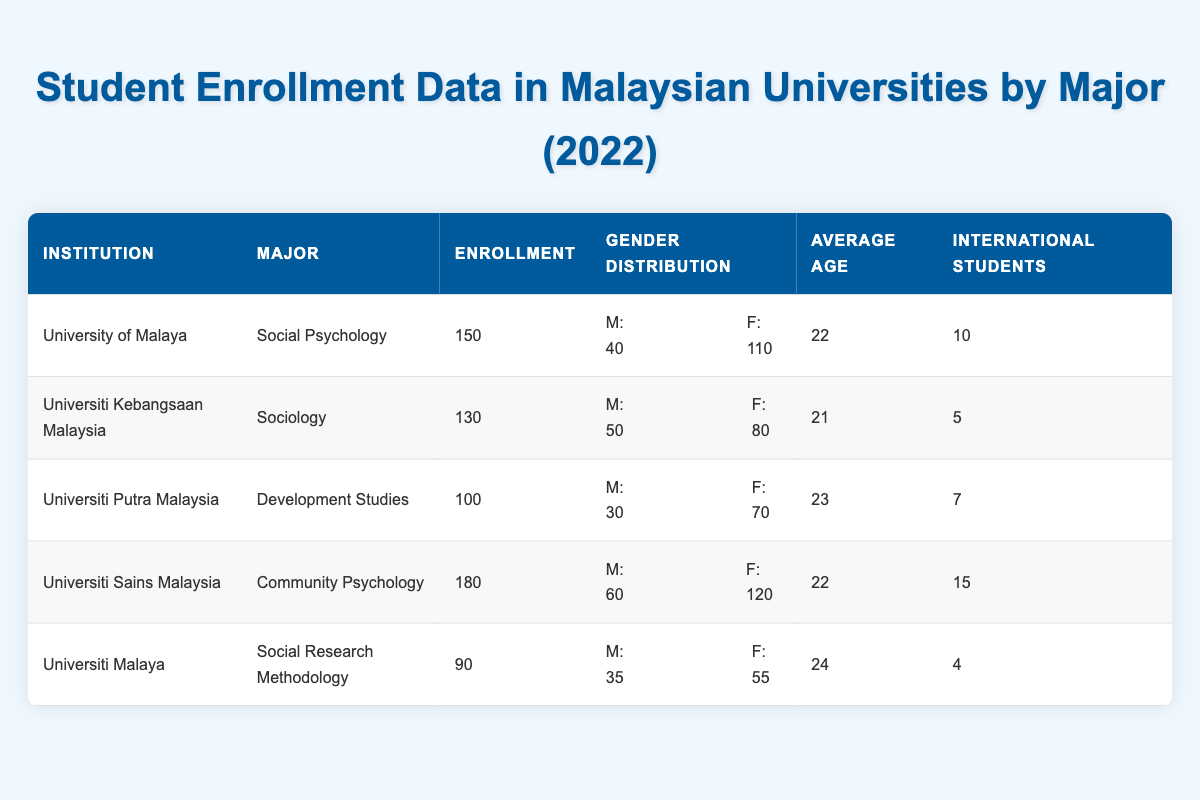What is the total enrollment for Social Psychology majors in Malaysian universities? According to the table, the enrollment numbers for Social Psychology are as follows: University of Malaya has 150. Therefore, the total enrollment for Social Psychology majors is 150.
Answer: 150 Which institution has the highest number of female students in their programs? From the data, Universiti Sains Malaysia has 120 female students in Community Psychology, which is the highest compared to other institutions.
Answer: Universiti Sains Malaysia What is the average age of students enrolled in Sociology? The table shows that the average age of students in Sociology at Universiti Kebangsaan Malaysia is 21.
Answer: 21 How many international students are enrolled in Development Studies? According to the table, Universiti Putra Malaysia has 7 international students enrolled in Development Studies.
Answer: 7 Is the average age of male students older than that of female students in Social Research Methodology? The average age of students for Social Research Methodology is 24 years. There is no age breakdown by gender given, so we cannot determine whether male students are older than female students. Therefore, the answer is no.
Answer: No What is the difference in enrollment between Community Psychology and Social Research Methodology? The enrollment numbers are: Community Psychology has 180 students, and Social Research Methodology has 90 students. The difference in their enrollment is 180 - 90 = 90.
Answer: 90 Which major has the lowest total enrollment among the listed programs? The enrollment data shows that Social Research Methodology has the lowest enrollment at 90 students compared to others which are higher.
Answer: Social Research Methodology How many male students are enrolled in universities compared to female students across all majors? Summing the male students: 40 (Social Psychology) + 50 (Sociology) + 30 (Development Studies) + 60 (Community Psychology) + 35 (Social Research Methodology) = 215 male students. For female students: 110 + 80 + 70 + 120 + 55 = 435 female students. Therefore, there are more female students than male students: 435 - 215 = 220.
Answer: 220 more female students What percentage of students in Community Psychology are international students? Community Psychology has an enrollment of 180 students, and there are 15 international students. The percentage of international students is (15/180) * 100 = 8.33%.
Answer: 8.33% 